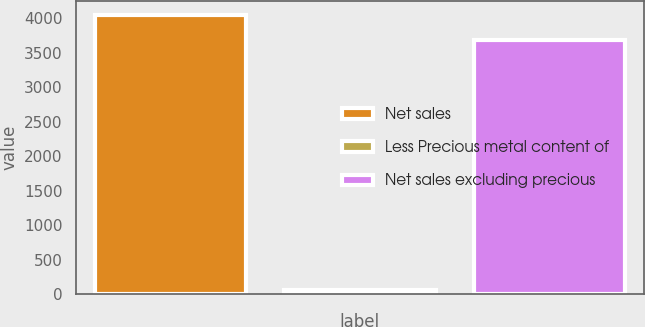Convert chart. <chart><loc_0><loc_0><loc_500><loc_500><bar_chart><fcel>Net sales<fcel>Less Precious metal content of<fcel>Net sales excluding precious<nl><fcel>4049.1<fcel>64.3<fcel>3681<nl></chart> 